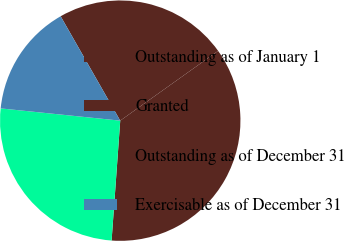<chart> <loc_0><loc_0><loc_500><loc_500><pie_chart><fcel>Outstanding as of January 1<fcel>Granted<fcel>Outstanding as of December 31<fcel>Exercisable as of December 31<nl><fcel>23.4%<fcel>36.0%<fcel>25.48%<fcel>15.12%<nl></chart> 